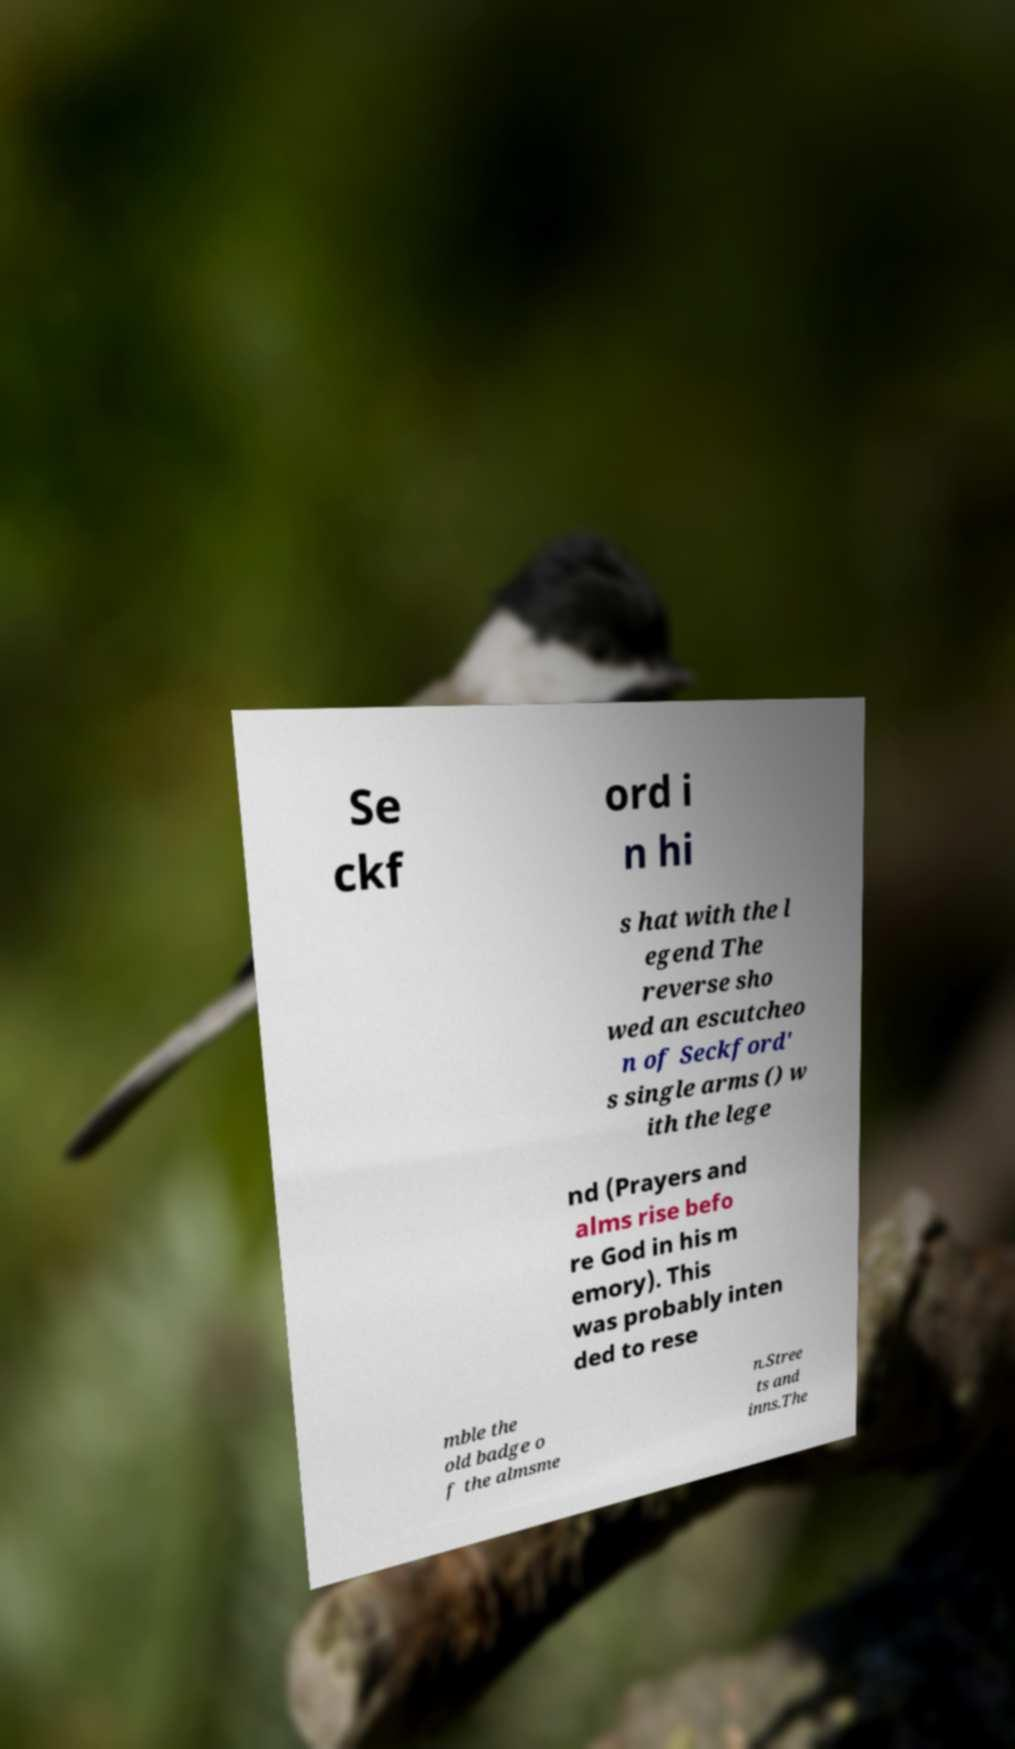Can you read and provide the text displayed in the image?This photo seems to have some interesting text. Can you extract and type it out for me? Se ckf ord i n hi s hat with the l egend The reverse sho wed an escutcheo n of Seckford' s single arms () w ith the lege nd (Prayers and alms rise befo re God in his m emory). This was probably inten ded to rese mble the old badge o f the almsme n.Stree ts and inns.The 